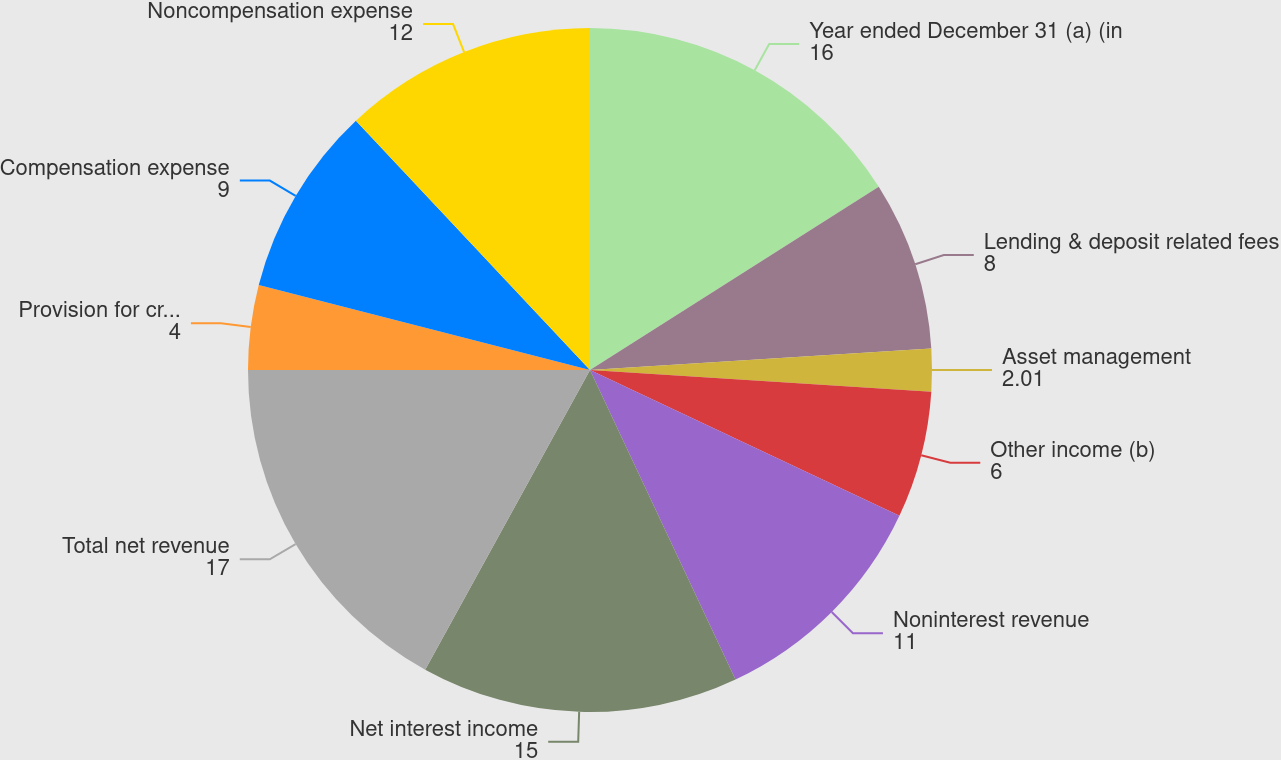Convert chart. <chart><loc_0><loc_0><loc_500><loc_500><pie_chart><fcel>Year ended December 31 (a) (in<fcel>Lending & deposit related fees<fcel>Asset management<fcel>Other income (b)<fcel>Noninterest revenue<fcel>Net interest income<fcel>Total net revenue<fcel>Provision for credit losses<fcel>Compensation expense<fcel>Noncompensation expense<nl><fcel>16.0%<fcel>8.0%<fcel>2.01%<fcel>6.0%<fcel>11.0%<fcel>15.0%<fcel>17.0%<fcel>4.0%<fcel>9.0%<fcel>12.0%<nl></chart> 